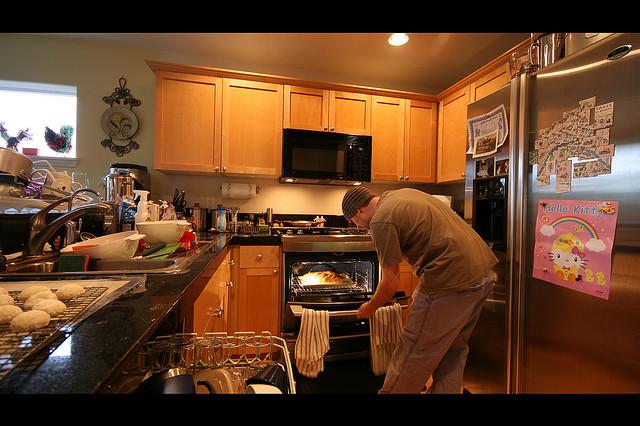What is in the packet?
Short answer required. Food. What is he cooking?
Concise answer only. Turkey. Is this a kitchen?
Quick response, please. Yes. Is there a hello kitty picture here?
Quick response, please. Yes. 